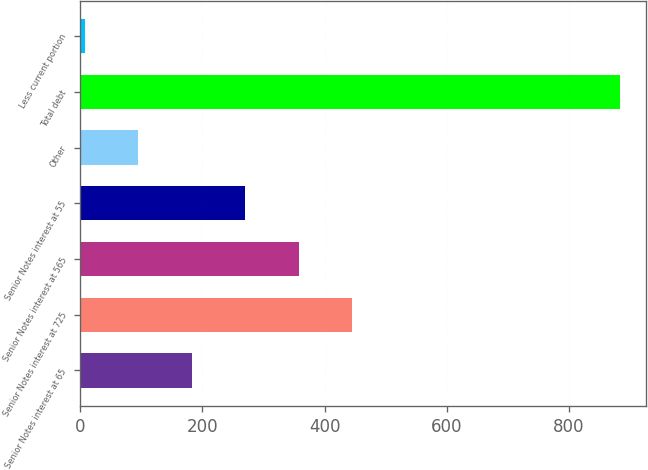Convert chart to OTSL. <chart><loc_0><loc_0><loc_500><loc_500><bar_chart><fcel>Senior Notes interest at 65<fcel>Senior Notes interest at 725<fcel>Senior Notes interest at 565<fcel>Senior Notes interest at 55<fcel>Other<fcel>Total debt<fcel>Less current portion<nl><fcel>182.2<fcel>445<fcel>357.4<fcel>269.8<fcel>94.6<fcel>883<fcel>7<nl></chart> 